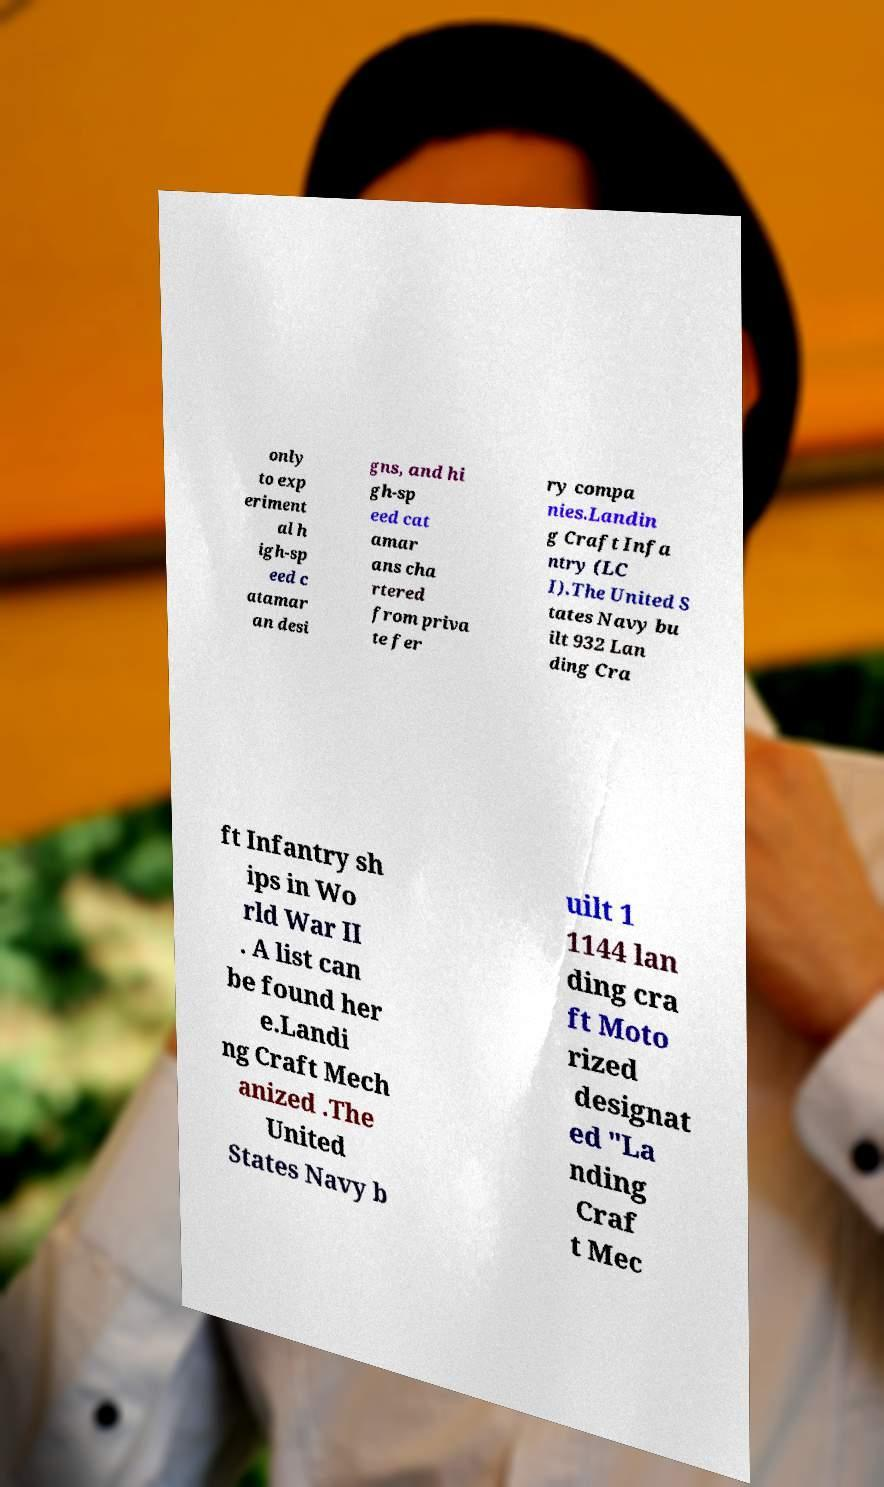Please read and relay the text visible in this image. What does it say? only to exp eriment al h igh-sp eed c atamar an desi gns, and hi gh-sp eed cat amar ans cha rtered from priva te fer ry compa nies.Landin g Craft Infa ntry (LC I).The United S tates Navy bu ilt 932 Lan ding Cra ft Infantry sh ips in Wo rld War II . A list can be found her e.Landi ng Craft Mech anized .The United States Navy b uilt 1 1144 lan ding cra ft Moto rized designat ed "La nding Craf t Mec 